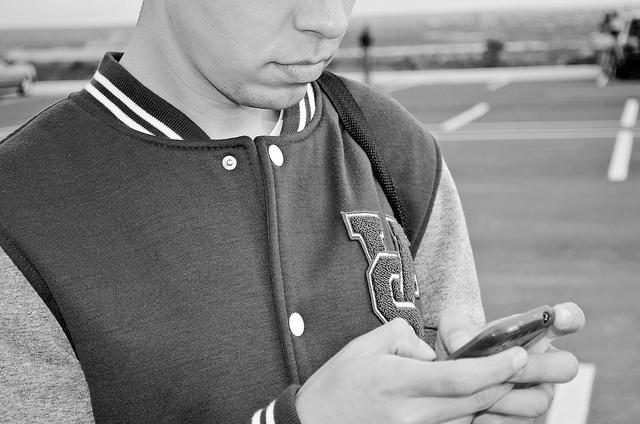What type of jacket is he wearing?
Quick response, please. Varsity. What is in the boy's hands?
Short answer required. Phone. What does the patch on the jacket indicate?
Be succinct. Varsity. 